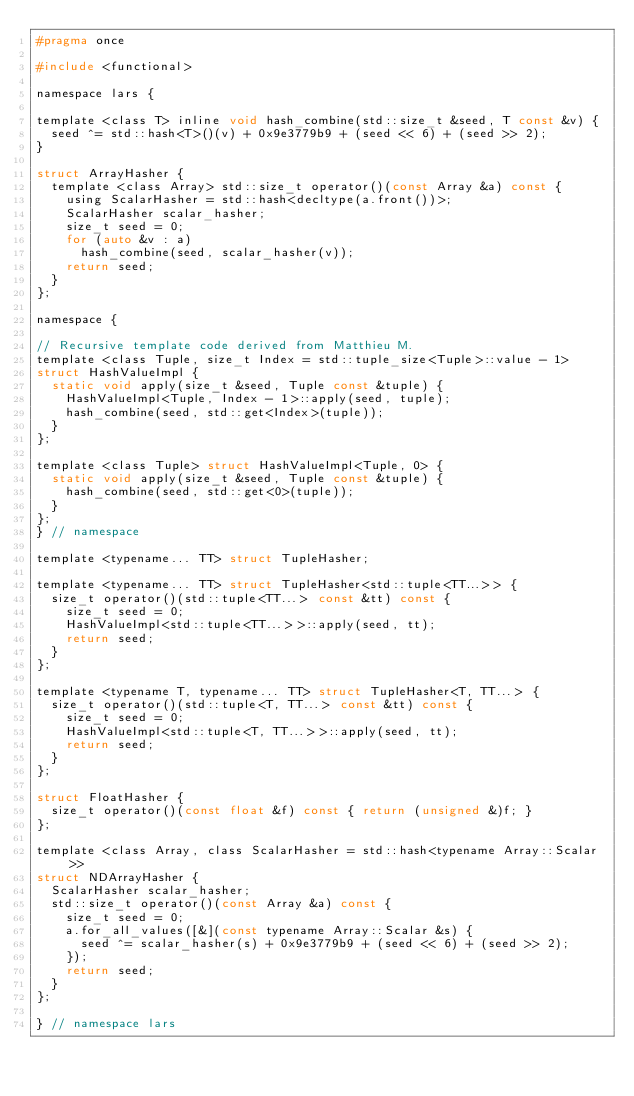<code> <loc_0><loc_0><loc_500><loc_500><_C_>#pragma once

#include <functional>

namespace lars {

template <class T> inline void hash_combine(std::size_t &seed, T const &v) {
  seed ^= std::hash<T>()(v) + 0x9e3779b9 + (seed << 6) + (seed >> 2);
}

struct ArrayHasher {
  template <class Array> std::size_t operator()(const Array &a) const {
    using ScalarHasher = std::hash<decltype(a.front())>;
    ScalarHasher scalar_hasher;
    size_t seed = 0;
    for (auto &v : a)
      hash_combine(seed, scalar_hasher(v));
    return seed;
  }
};

namespace {

// Recursive template code derived from Matthieu M.
template <class Tuple, size_t Index = std::tuple_size<Tuple>::value - 1>
struct HashValueImpl {
  static void apply(size_t &seed, Tuple const &tuple) {
    HashValueImpl<Tuple, Index - 1>::apply(seed, tuple);
    hash_combine(seed, std::get<Index>(tuple));
  }
};

template <class Tuple> struct HashValueImpl<Tuple, 0> {
  static void apply(size_t &seed, Tuple const &tuple) {
    hash_combine(seed, std::get<0>(tuple));
  }
};
} // namespace

template <typename... TT> struct TupleHasher;

template <typename... TT> struct TupleHasher<std::tuple<TT...>> {
  size_t operator()(std::tuple<TT...> const &tt) const {
    size_t seed = 0;
    HashValueImpl<std::tuple<TT...>>::apply(seed, tt);
    return seed;
  }
};

template <typename T, typename... TT> struct TupleHasher<T, TT...> {
  size_t operator()(std::tuple<T, TT...> const &tt) const {
    size_t seed = 0;
    HashValueImpl<std::tuple<T, TT...>>::apply(seed, tt);
    return seed;
  }
};

struct FloatHasher {
  size_t operator()(const float &f) const { return (unsigned &)f; }
};

template <class Array, class ScalarHasher = std::hash<typename Array::Scalar>>
struct NDArrayHasher {
  ScalarHasher scalar_hasher;
  std::size_t operator()(const Array &a) const {
    size_t seed = 0;
    a.for_all_values([&](const typename Array::Scalar &s) {
      seed ^= scalar_hasher(s) + 0x9e3779b9 + (seed << 6) + (seed >> 2);
    });
    return seed;
  }
};

} // namespace lars
</code> 